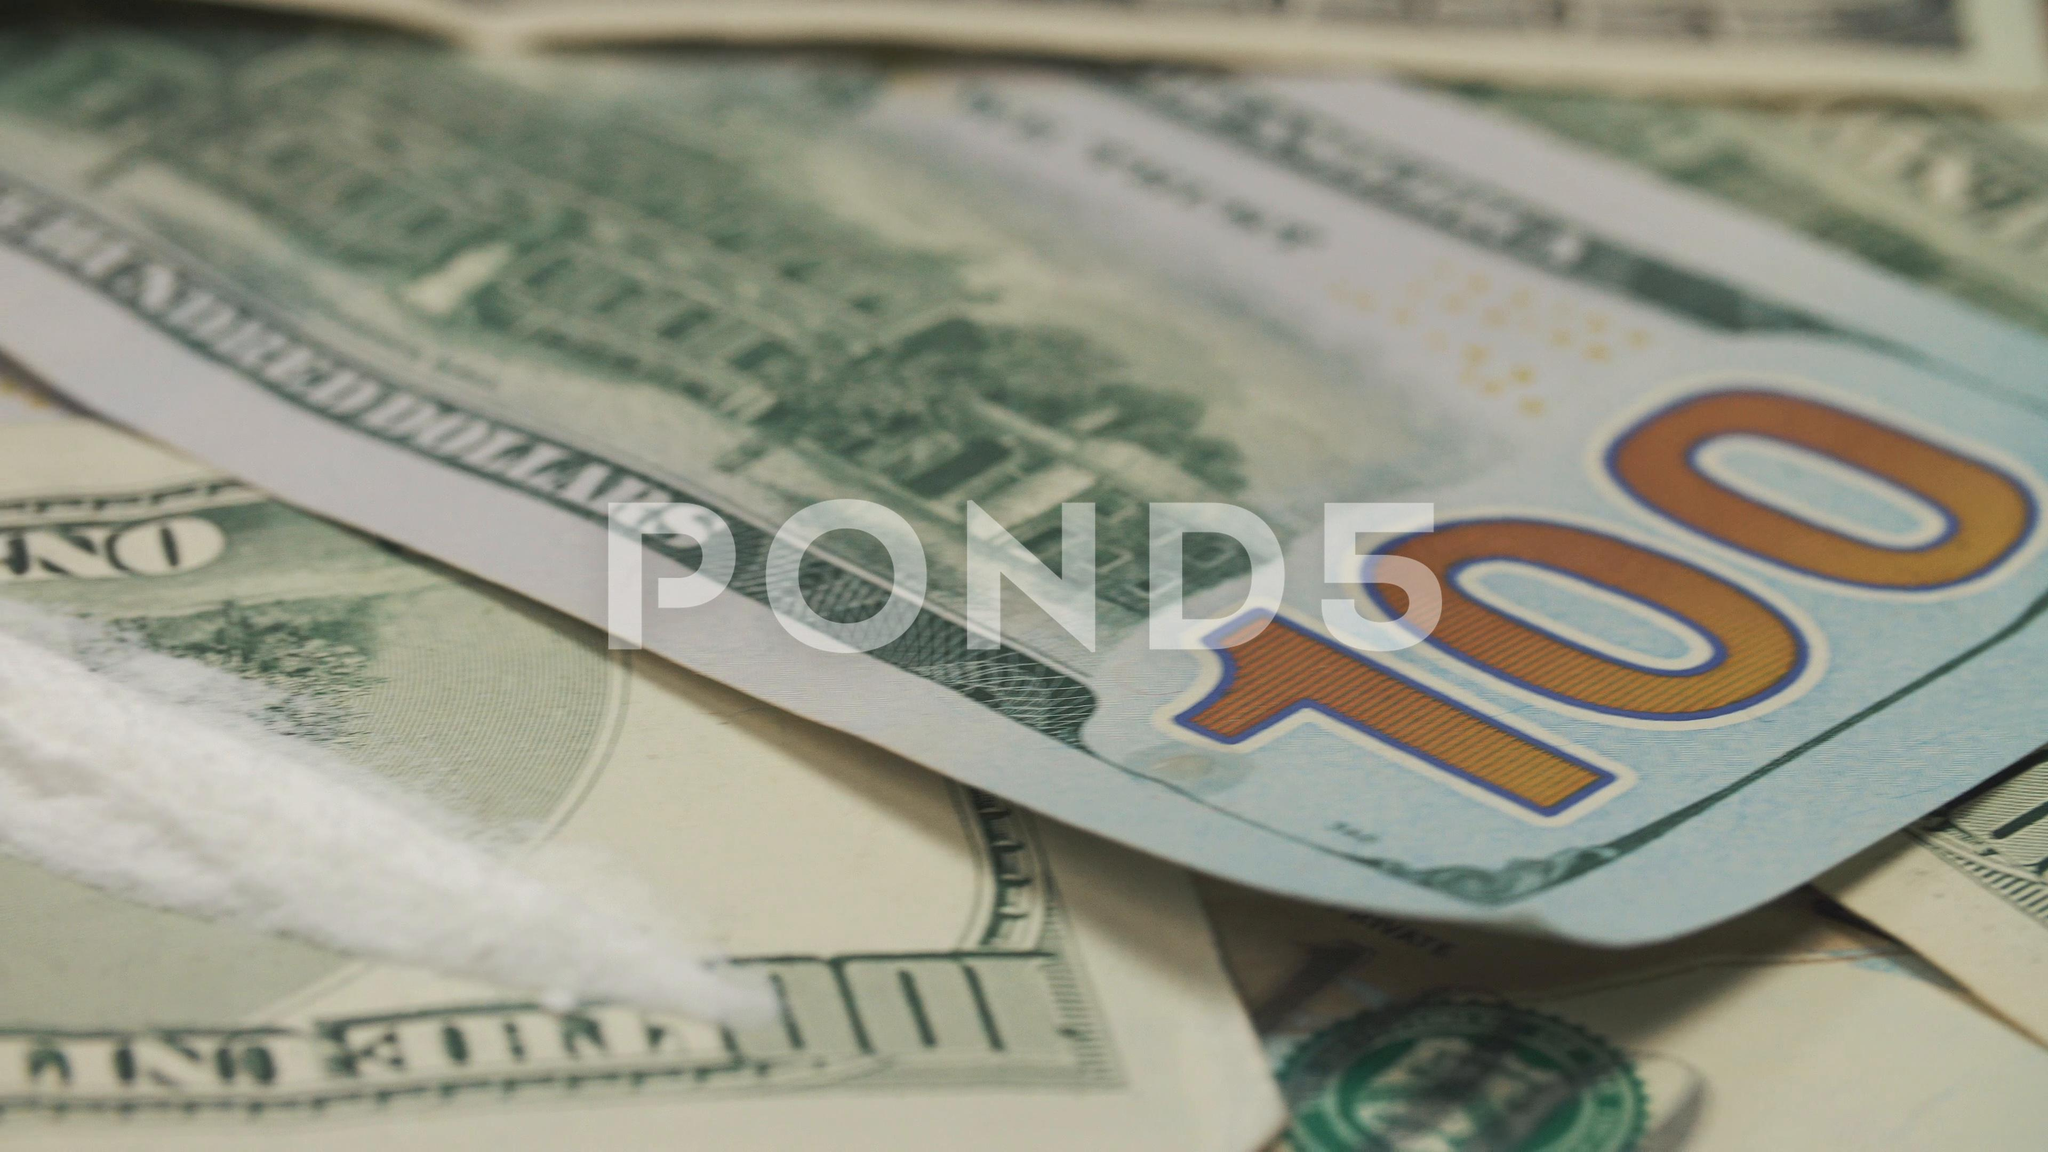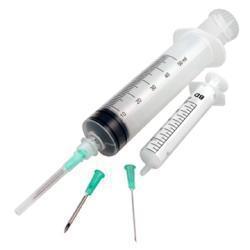The first image is the image on the left, the second image is the image on the right. For the images shown, is this caption "American money is visible in one of the images." true? Answer yes or no. Yes. The first image is the image on the left, the second image is the image on the right. Given the left and right images, does the statement "The right image contains paper money and a syringe." hold true? Answer yes or no. No. 